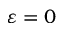<formula> <loc_0><loc_0><loc_500><loc_500>\varepsilon = 0</formula> 